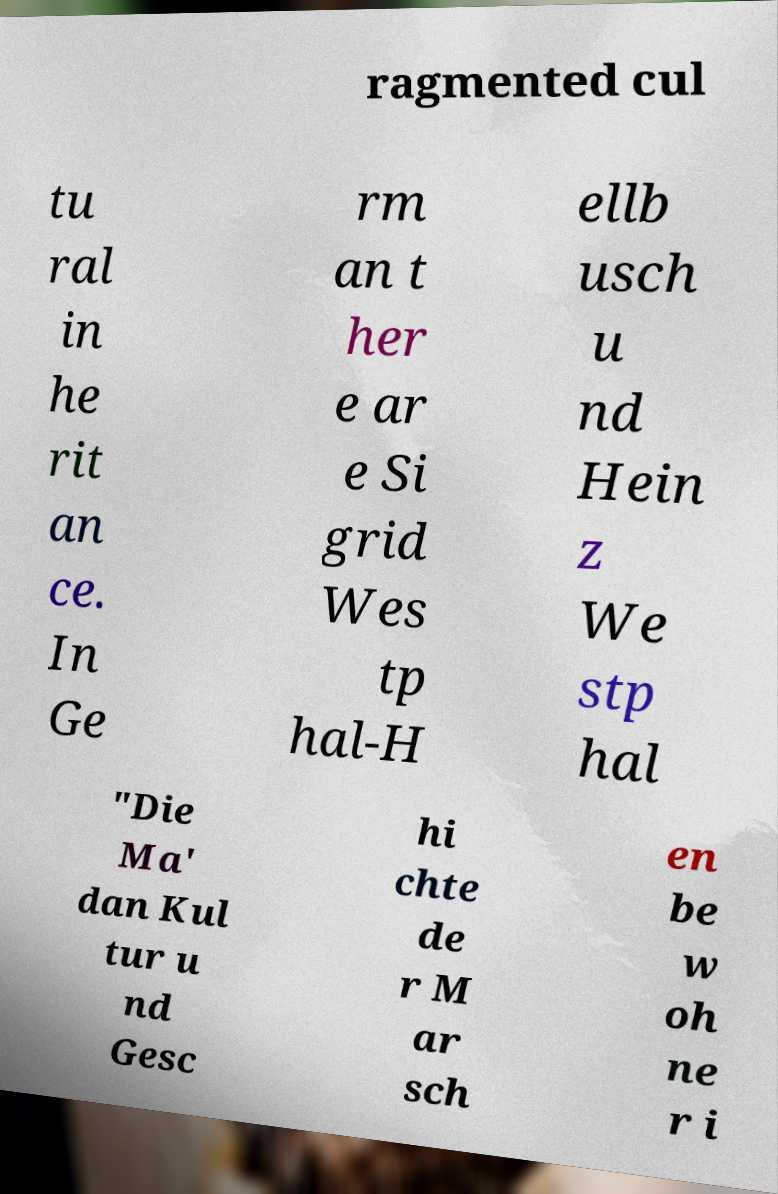I need the written content from this picture converted into text. Can you do that? ragmented cul tu ral in he rit an ce. In Ge rm an t her e ar e Si grid Wes tp hal-H ellb usch u nd Hein z We stp hal "Die Ma' dan Kul tur u nd Gesc hi chte de r M ar sch en be w oh ne r i 